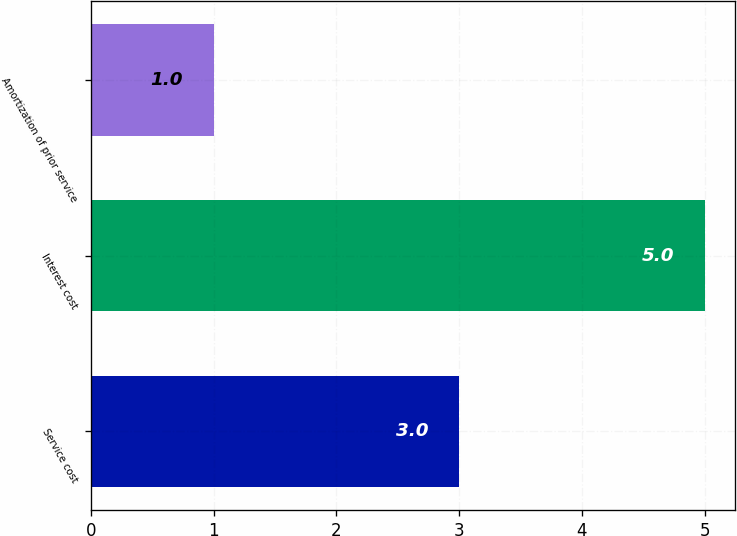Convert chart. <chart><loc_0><loc_0><loc_500><loc_500><bar_chart><fcel>Service cost<fcel>Interest cost<fcel>Amortization of prior service<nl><fcel>3<fcel>5<fcel>1<nl></chart> 